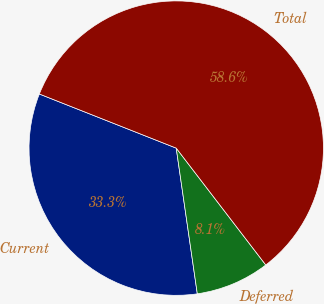Convert chart to OTSL. <chart><loc_0><loc_0><loc_500><loc_500><pie_chart><fcel>Current<fcel>Deferred<fcel>Total<nl><fcel>33.28%<fcel>8.12%<fcel>58.6%<nl></chart> 